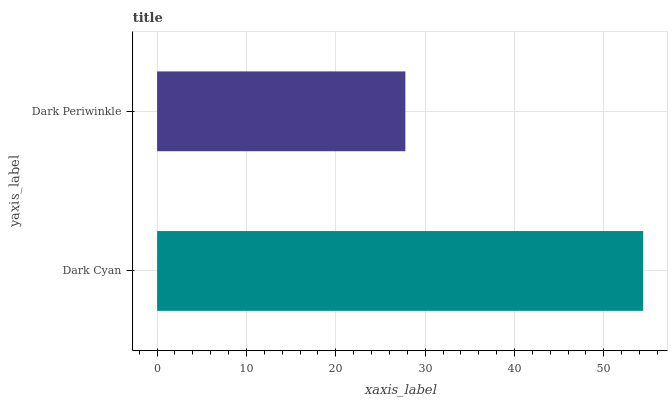Is Dark Periwinkle the minimum?
Answer yes or no. Yes. Is Dark Cyan the maximum?
Answer yes or no. Yes. Is Dark Periwinkle the maximum?
Answer yes or no. No. Is Dark Cyan greater than Dark Periwinkle?
Answer yes or no. Yes. Is Dark Periwinkle less than Dark Cyan?
Answer yes or no. Yes. Is Dark Periwinkle greater than Dark Cyan?
Answer yes or no. No. Is Dark Cyan less than Dark Periwinkle?
Answer yes or no. No. Is Dark Cyan the high median?
Answer yes or no. Yes. Is Dark Periwinkle the low median?
Answer yes or no. Yes. Is Dark Periwinkle the high median?
Answer yes or no. No. Is Dark Cyan the low median?
Answer yes or no. No. 